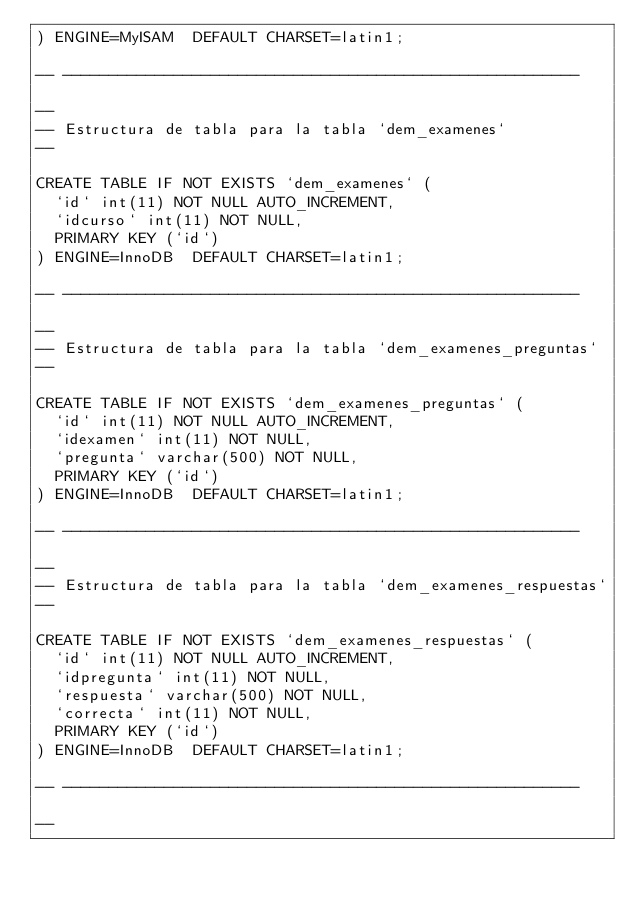Convert code to text. <code><loc_0><loc_0><loc_500><loc_500><_SQL_>) ENGINE=MyISAM  DEFAULT CHARSET=latin1;

-- --------------------------------------------------------

--
-- Estructura de tabla para la tabla `dem_examenes`
--

CREATE TABLE IF NOT EXISTS `dem_examenes` (
  `id` int(11) NOT NULL AUTO_INCREMENT,
  `idcurso` int(11) NOT NULL,
  PRIMARY KEY (`id`)
) ENGINE=InnoDB  DEFAULT CHARSET=latin1;

-- --------------------------------------------------------

--
-- Estructura de tabla para la tabla `dem_examenes_preguntas`
--

CREATE TABLE IF NOT EXISTS `dem_examenes_preguntas` (
  `id` int(11) NOT NULL AUTO_INCREMENT,
  `idexamen` int(11) NOT NULL,
  `pregunta` varchar(500) NOT NULL,
  PRIMARY KEY (`id`)
) ENGINE=InnoDB  DEFAULT CHARSET=latin1;

-- --------------------------------------------------------

--
-- Estructura de tabla para la tabla `dem_examenes_respuestas`
--

CREATE TABLE IF NOT EXISTS `dem_examenes_respuestas` (
  `id` int(11) NOT NULL AUTO_INCREMENT,
  `idpregunta` int(11) NOT NULL,
  `respuesta` varchar(500) NOT NULL,
  `correcta` int(11) NOT NULL,
  PRIMARY KEY (`id`)
) ENGINE=InnoDB  DEFAULT CHARSET=latin1;

-- --------------------------------------------------------

--</code> 